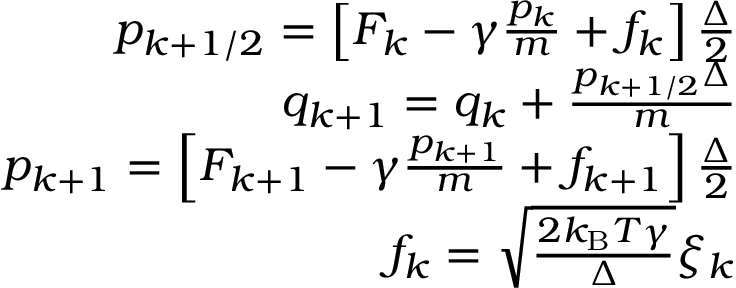<formula> <loc_0><loc_0><loc_500><loc_500>\begin{array} { r } { p _ { k + 1 / 2 } = \left [ F _ { k } - \gamma \frac { p _ { k } } { m } + f _ { k } \right ] \frac { \Delta } { 2 } } \\ { q _ { k + 1 } = q _ { k } + \frac { p _ { k + 1 / 2 } \Delta } { m } } \\ { p _ { k + 1 } = \left [ F _ { k + 1 } - \gamma \frac { p _ { k + 1 } } { m } + f _ { k + 1 } \right ] \frac { \Delta } { 2 } } \\ { f _ { k } = \sqrt { \frac { 2 k _ { B } T \gamma } { \Delta } } \xi _ { k } } \end{array}</formula> 